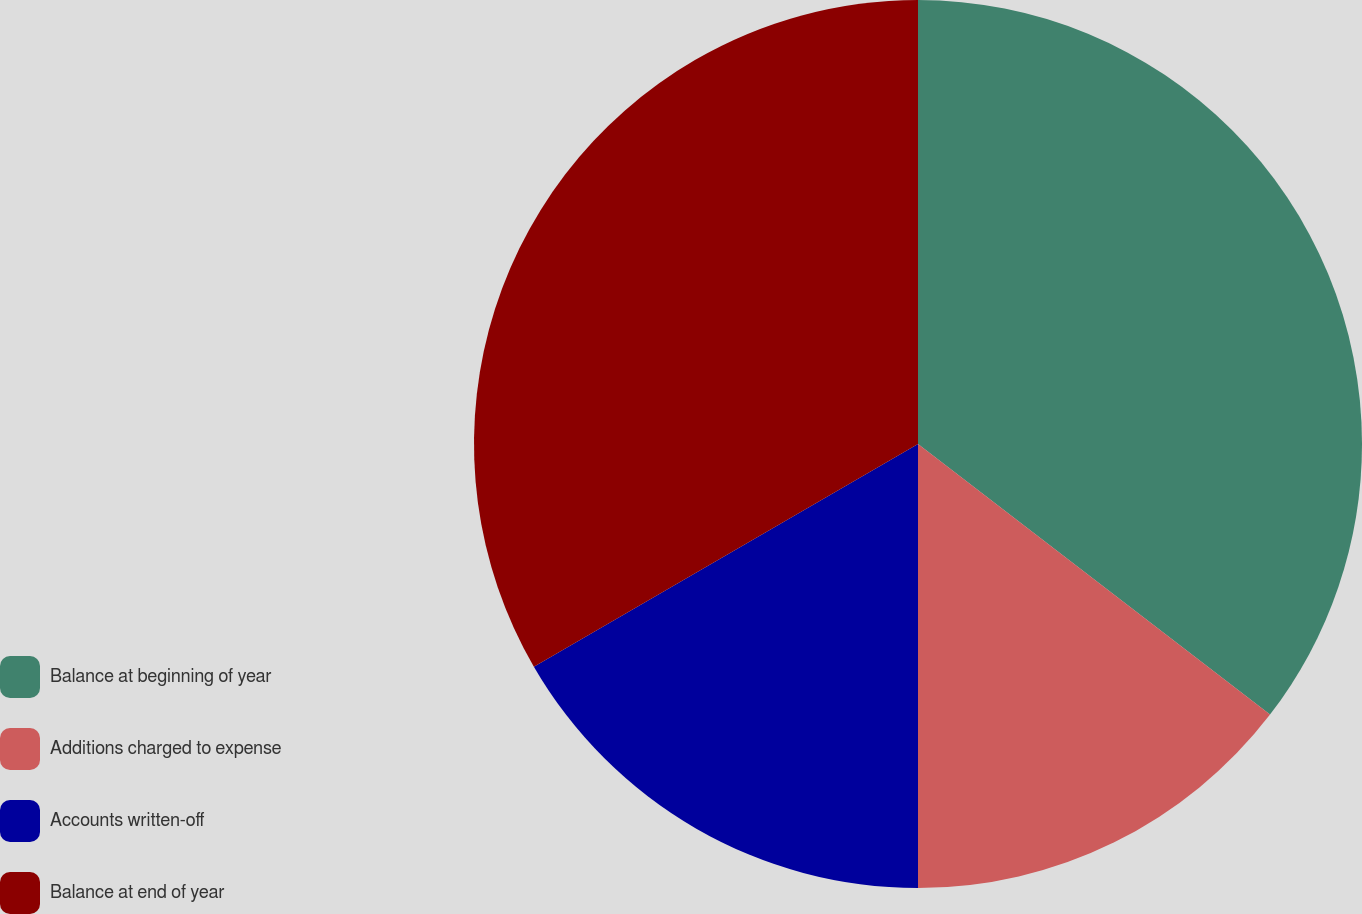Convert chart to OTSL. <chart><loc_0><loc_0><loc_500><loc_500><pie_chart><fcel>Balance at beginning of year<fcel>Additions charged to expense<fcel>Accounts written-off<fcel>Balance at end of year<nl><fcel>35.43%<fcel>14.57%<fcel>16.64%<fcel>33.36%<nl></chart> 